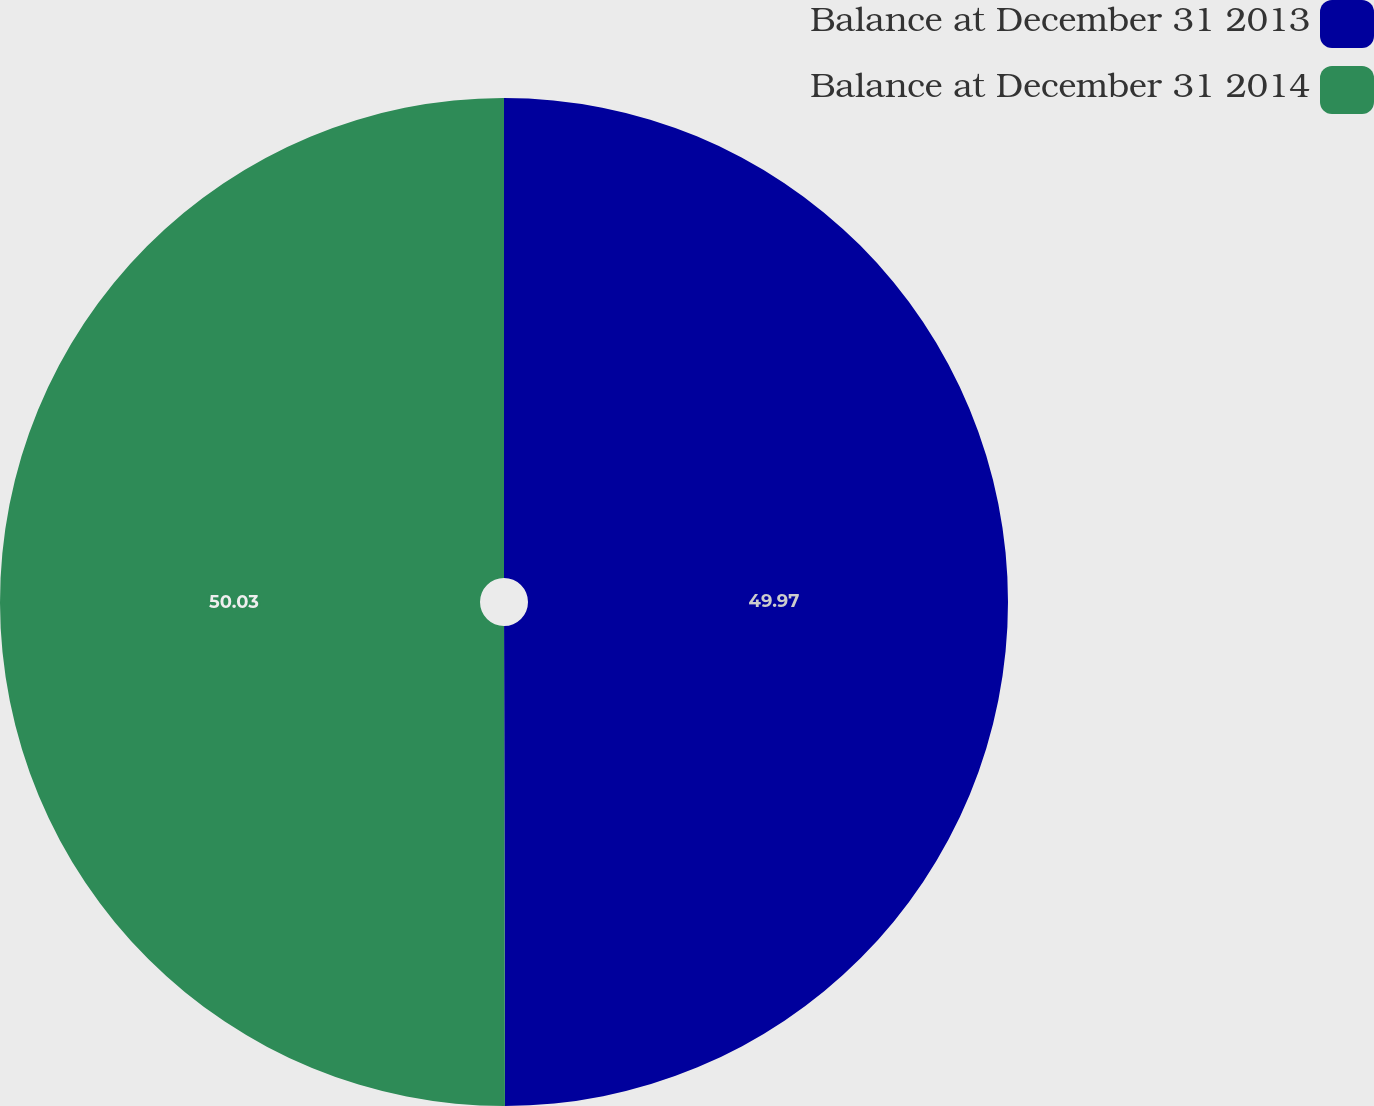<chart> <loc_0><loc_0><loc_500><loc_500><pie_chart><fcel>Balance at December 31 2013<fcel>Balance at December 31 2014<nl><fcel>49.97%<fcel>50.03%<nl></chart> 